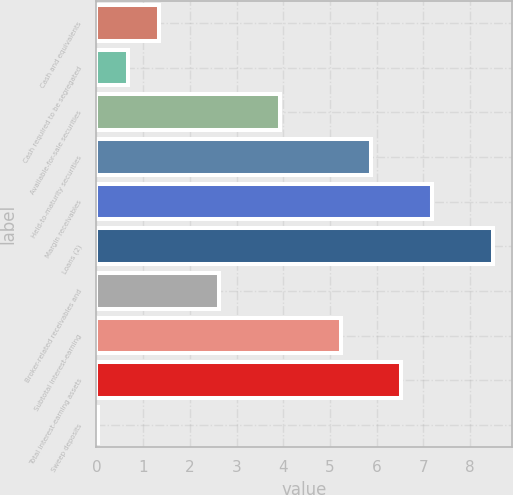<chart> <loc_0><loc_0><loc_500><loc_500><bar_chart><fcel>Cash and equivalents<fcel>Cash required to be segregated<fcel>Available-for-sale securities<fcel>Held-to-maturity securities<fcel>Margin receivables<fcel>Loans (2)<fcel>Broker-related receivables and<fcel>Subtotal interest-earning<fcel>Total interest-earning assets<fcel>Sweep deposits<nl><fcel>1.33<fcel>0.68<fcel>3.93<fcel>5.88<fcel>7.18<fcel>8.48<fcel>2.63<fcel>5.23<fcel>6.53<fcel>0.03<nl></chart> 